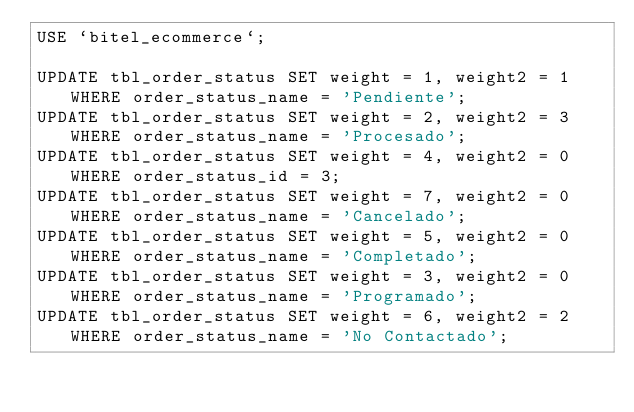<code> <loc_0><loc_0><loc_500><loc_500><_SQL_>USE `bitel_ecommerce`;

UPDATE tbl_order_status SET weight = 1, weight2 = 1 WHERE order_status_name = 'Pendiente';
UPDATE tbl_order_status SET weight = 2, weight2 = 3 WHERE order_status_name = 'Procesado';
UPDATE tbl_order_status SET weight = 4, weight2 = 0 WHERE order_status_id = 3;
UPDATE tbl_order_status SET weight = 7, weight2 = 0 WHERE order_status_name = 'Cancelado';
UPDATE tbl_order_status SET weight = 5, weight2 = 0 WHERE order_status_name = 'Completado';
UPDATE tbl_order_status SET weight = 3, weight2 = 0 WHERE order_status_name = 'Programado';
UPDATE tbl_order_status SET weight = 6, weight2 = 2 WHERE order_status_name = 'No Contactado';
</code> 